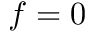<formula> <loc_0><loc_0><loc_500><loc_500>f = 0</formula> 